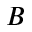<formula> <loc_0><loc_0><loc_500><loc_500>B</formula> 